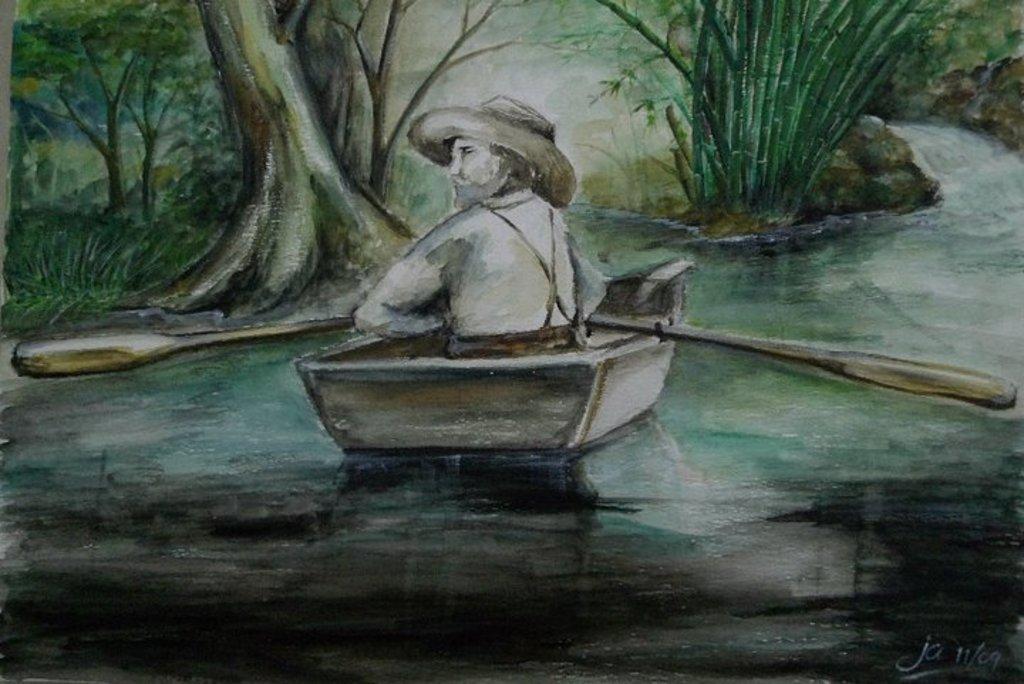Can you describe this image briefly? This is a painting and in this painting we can see a person sitting in a boat and holding paddles and this boat is on water and in the background we can see plants and trees. 